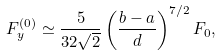Convert formula to latex. <formula><loc_0><loc_0><loc_500><loc_500>F ^ { ( 0 ) } _ { y } \simeq \frac { 5 } { 3 2 \sqrt { 2 } } \left ( \frac { b - a } { d } \right ) ^ { 7 / 2 } F _ { 0 } ,</formula> 